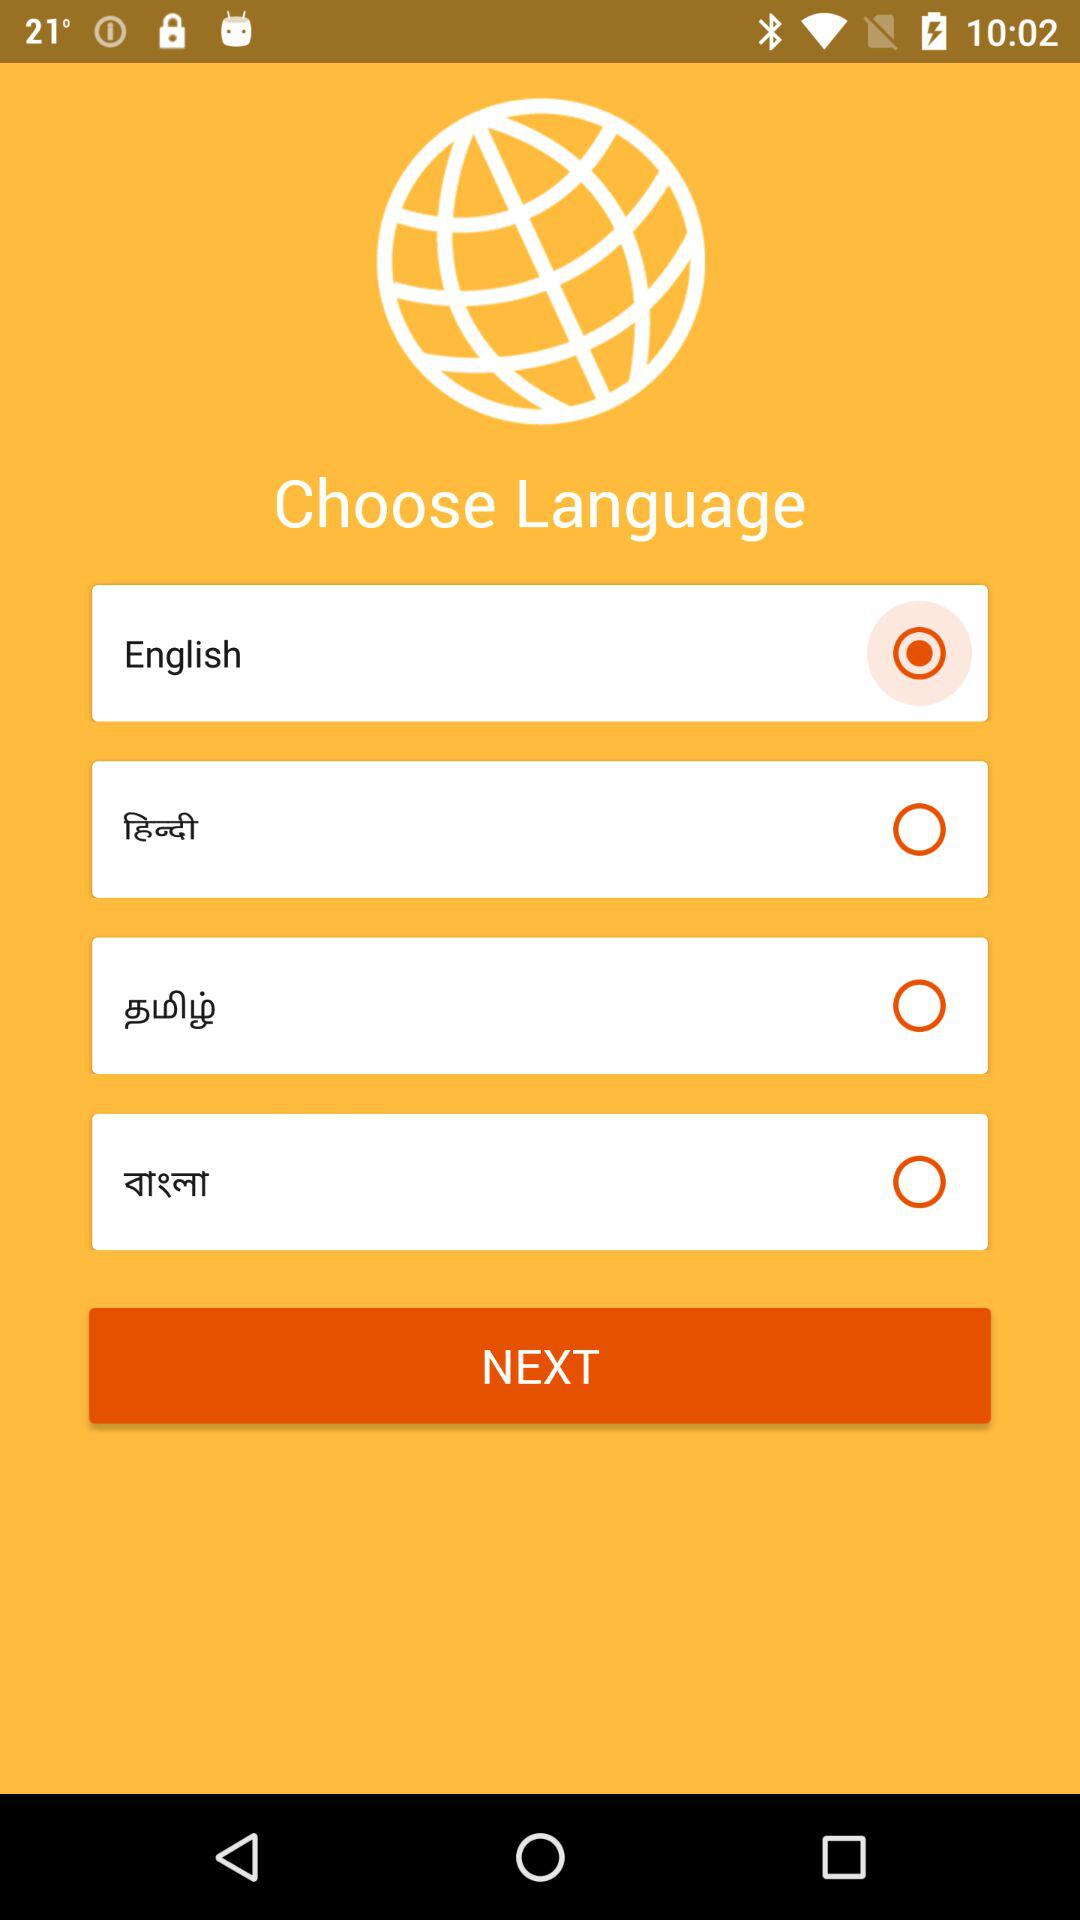How many languages are available to choose from?
Answer the question using a single word or phrase. 4 